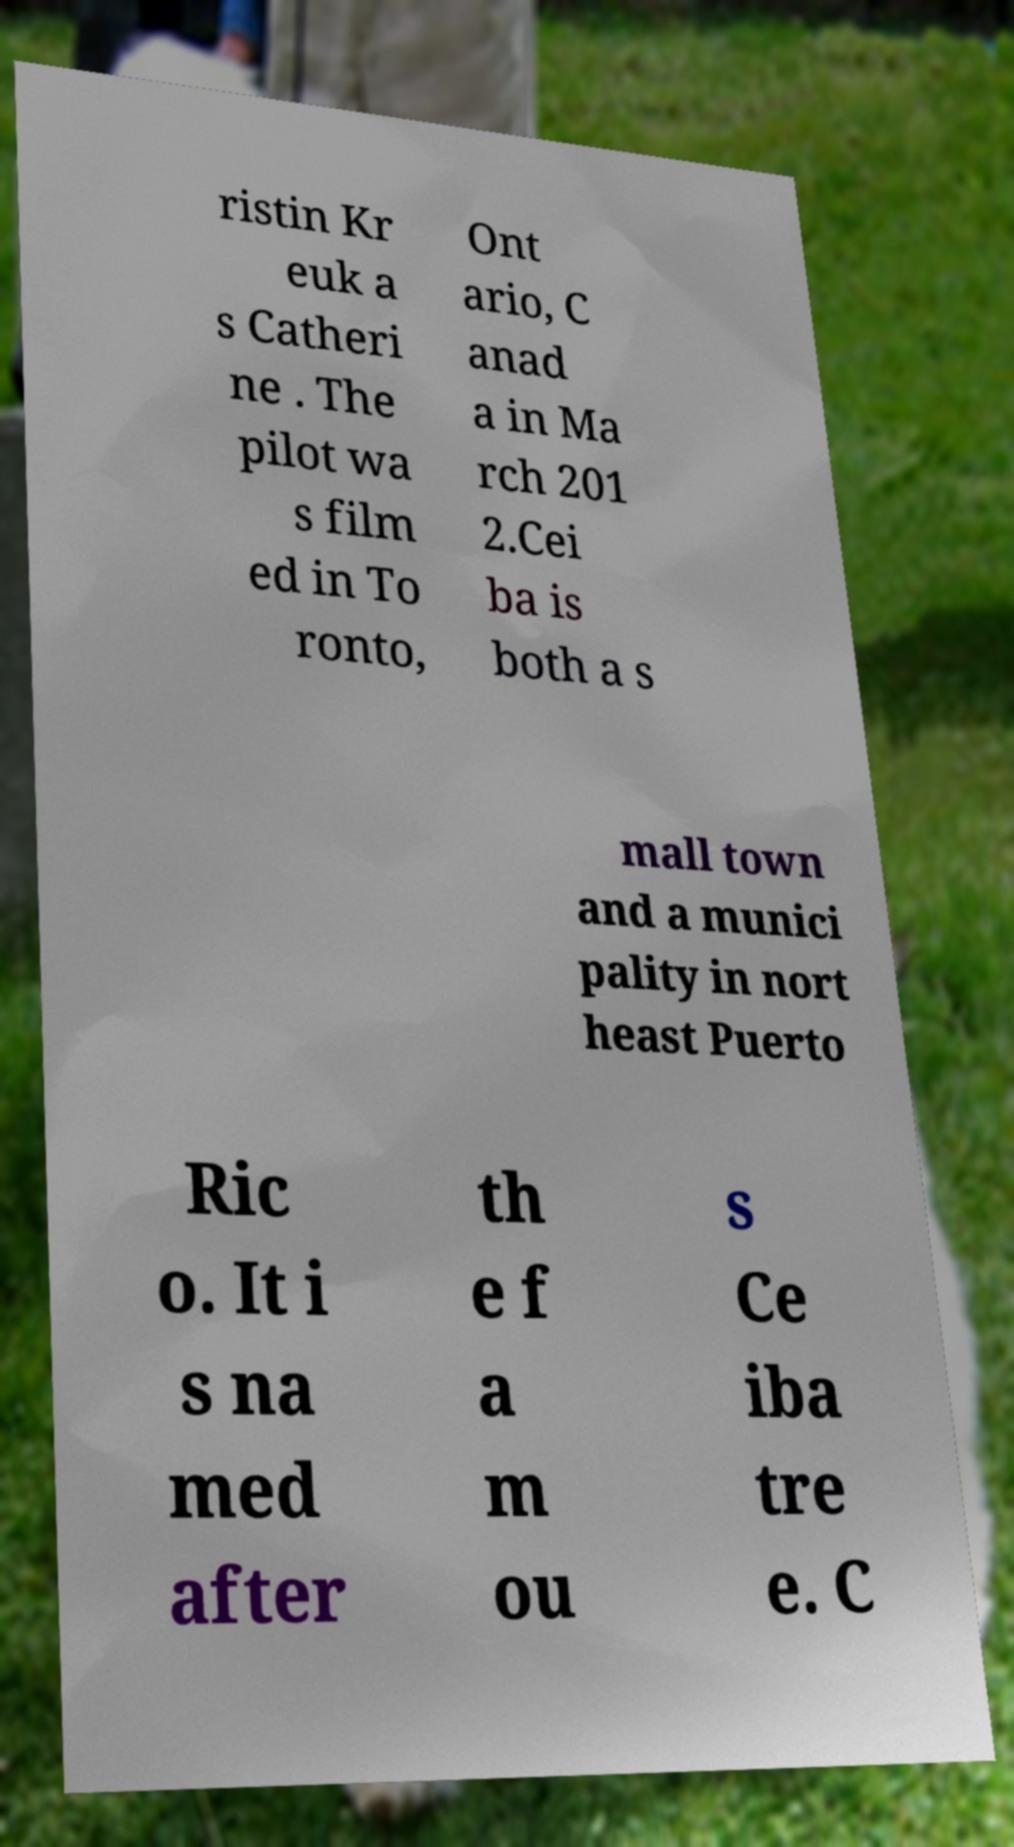Please identify and transcribe the text found in this image. ristin Kr euk a s Catheri ne . The pilot wa s film ed in To ronto, Ont ario, C anad a in Ma rch 201 2.Cei ba is both a s mall town and a munici pality in nort heast Puerto Ric o. It i s na med after th e f a m ou s Ce iba tre e. C 